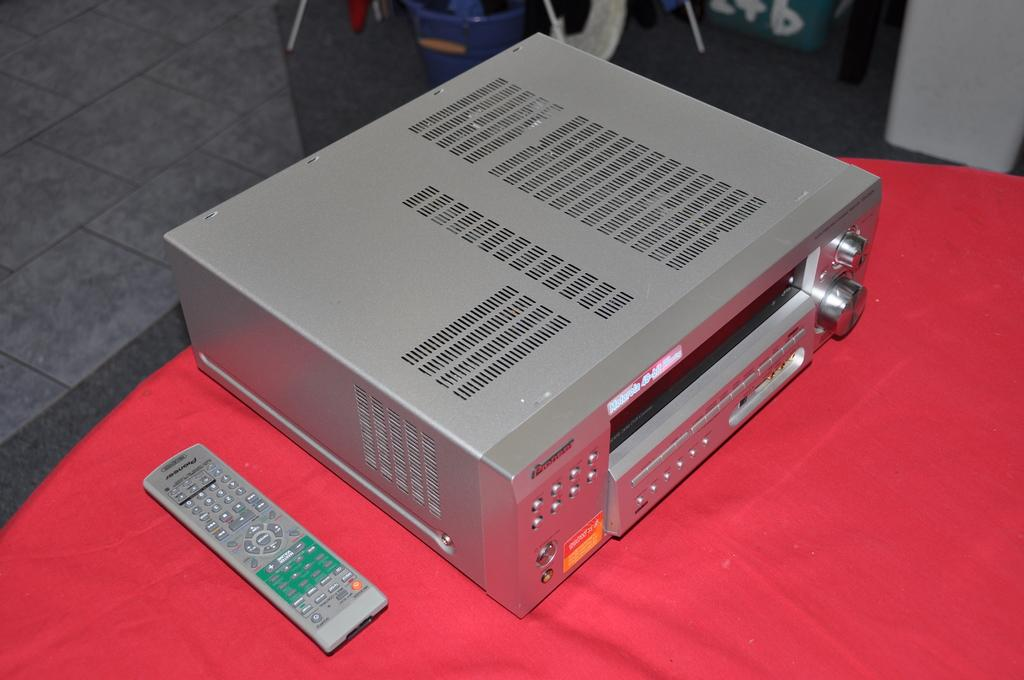<image>
Share a concise interpretation of the image provided. An old television device from Pioneer that plays 48-bit. 